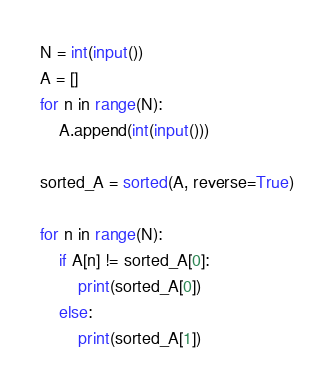<code> <loc_0><loc_0><loc_500><loc_500><_Python_>N = int(input())
A = []
for n in range(N):
    A.append(int(input()))

sorted_A = sorted(A, reverse=True)

for n in range(N):
    if A[n] != sorted_A[0]:
        print(sorted_A[0])
    else:
        print(sorted_A[1])
</code> 